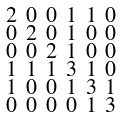<formula> <loc_0><loc_0><loc_500><loc_500>\begin{smallmatrix} 2 & 0 & 0 & 1 & 1 & 0 \\ 0 & 2 & 0 & 1 & 0 & 0 \\ 0 & 0 & 2 & 1 & 0 & 0 \\ 1 & 1 & 1 & 3 & 1 & 0 \\ 1 & 0 & 0 & 1 & 3 & 1 \\ 0 & 0 & 0 & 0 & 1 & 3 \end{smallmatrix}</formula> 